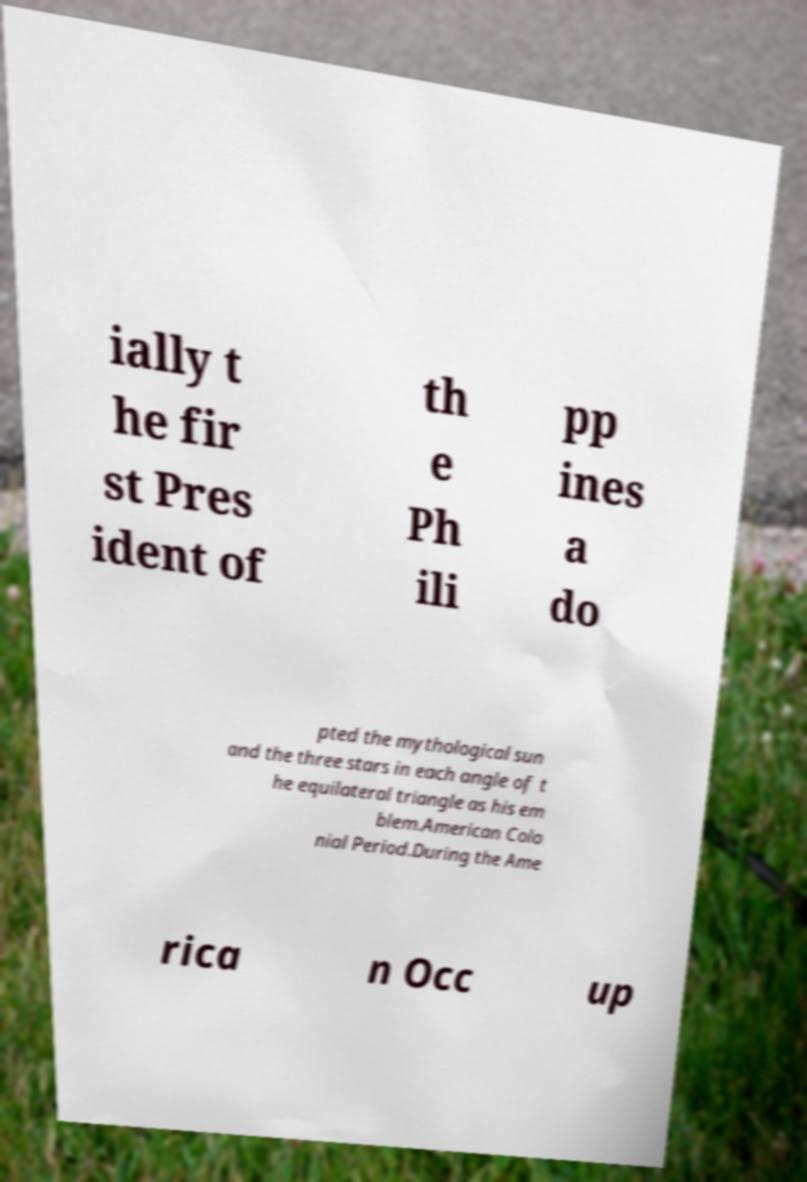I need the written content from this picture converted into text. Can you do that? ially t he fir st Pres ident of th e Ph ili pp ines a do pted the mythological sun and the three stars in each angle of t he equilateral triangle as his em blem.American Colo nial Period.During the Ame rica n Occ up 